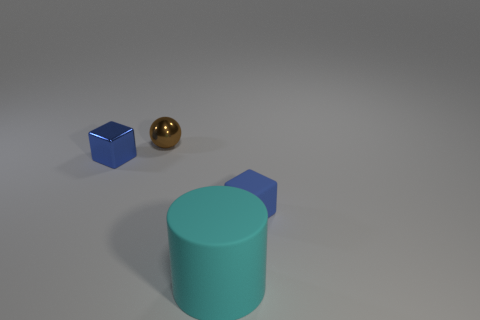Does the block to the left of the big cyan matte object have the same color as the block that is on the right side of the matte cylinder?
Offer a very short reply. Yes. What number of cyan things are either rubber objects or metal things?
Make the answer very short. 1. Is the number of blue matte cubes that are behind the tiny blue metallic object less than the number of small things to the left of the sphere?
Ensure brevity in your answer.  Yes. Are there any other blocks of the same size as the blue rubber block?
Offer a terse response. Yes. Does the blue object that is on the left side of the ball have the same size as the big cyan matte thing?
Keep it short and to the point. No. Are there more large cyan rubber spheres than small blue rubber objects?
Offer a very short reply. No. Is there another metallic thing of the same shape as the tiny blue metal object?
Make the answer very short. No. There is a small blue object in front of the blue metal block; what is its shape?
Ensure brevity in your answer.  Cube. What number of cyan cylinders are behind the tiny blue block that is right of the blue object to the left of the small brown sphere?
Offer a very short reply. 0. Is the color of the cube that is right of the ball the same as the big matte object?
Provide a succinct answer. No. 